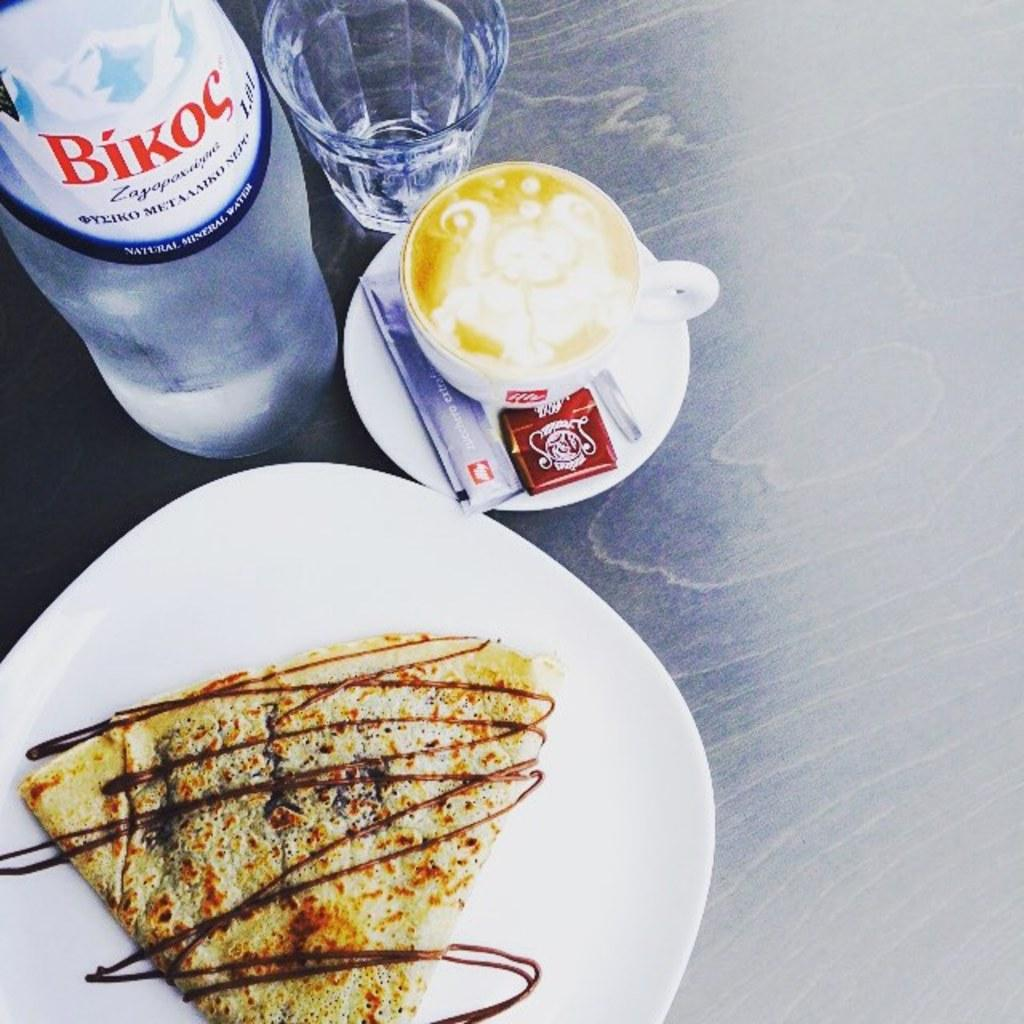Provide a one-sentence caption for the provided image. A dessert pancakes sits on a table with a cappuccino and a bottle of Bikoc water. 